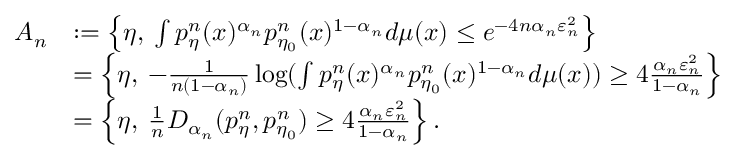<formula> <loc_0><loc_0><loc_500><loc_500>\begin{array} { r l } { A _ { n } } & { \colon = \left \{ \eta , \, \int p _ { \eta } ^ { n } ( x ) ^ { \alpha _ { n } } p _ { \eta _ { 0 } } ^ { n } ( x ) ^ { 1 - \alpha _ { n } } d \mu ( x ) \leq e ^ { - 4 n \alpha _ { n } \varepsilon _ { n } ^ { 2 } } \right \} } \\ & { = \left \{ \eta , \, - \frac { 1 } { n ( 1 - \alpha _ { n } ) } \log ( \int p _ { \eta } ^ { n } ( x ) ^ { \alpha _ { n } } p _ { \eta _ { 0 } } ^ { n } ( x ) ^ { 1 - \alpha _ { n } } d \mu ( x ) ) \geq 4 \frac { \alpha _ { n } \varepsilon _ { n } ^ { 2 } } { 1 - \alpha _ { n } } \right \} } \\ & { = \left \{ \eta , \, \frac { 1 } { n } D _ { \alpha _ { n } } ( p _ { \eta } ^ { n } , p _ { \eta _ { 0 } } ^ { n } ) \geq 4 \frac { \alpha _ { n } \varepsilon _ { n } ^ { 2 } } { 1 - \alpha _ { n } } \right \} . } \end{array}</formula> 